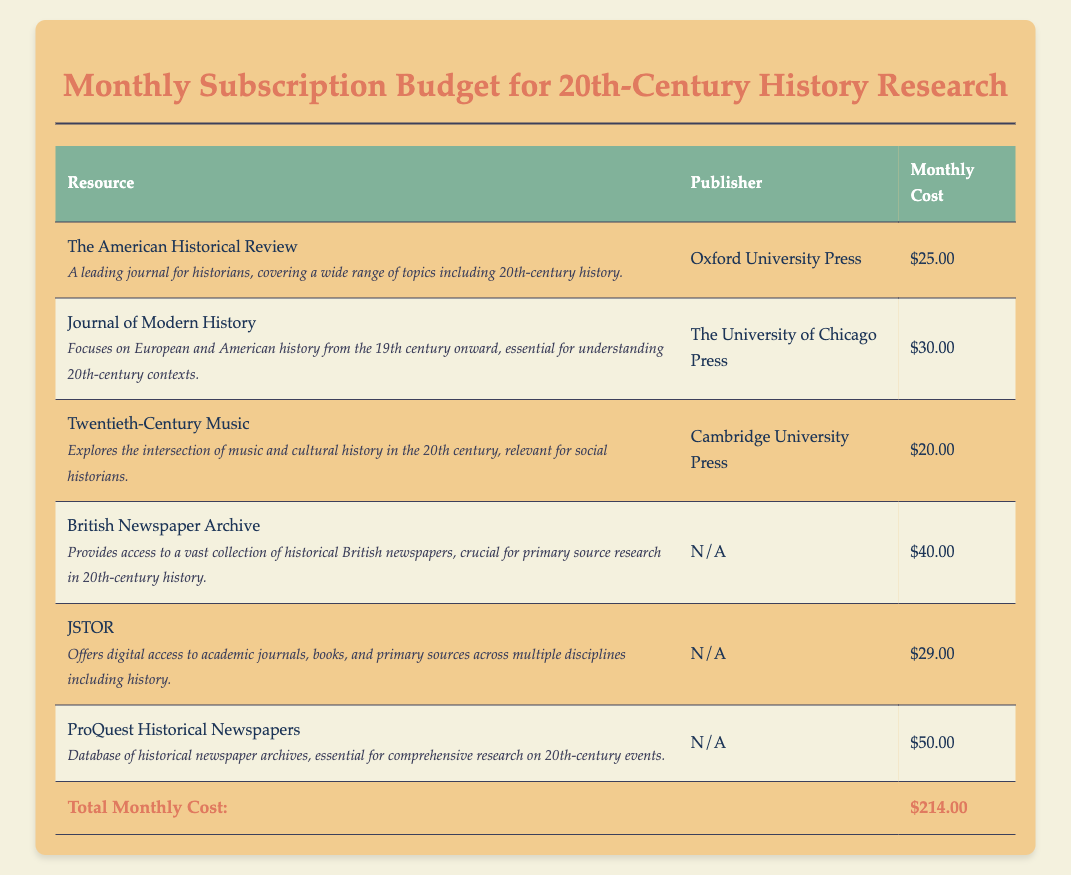What is the total monthly cost? The total monthly cost is listed at the bottom of the document in the table.
Answer: $214.00 Which publisher produces the Journal of Modern History? The publisher of the Journal of Modern History is specified in the second row of the table.
Answer: The University of Chicago Press How much does access to the British Newspaper Archive cost monthly? The monthly cost for the British Newspaper Archive is shown in the corresponding row of the table.
Answer: $40.00 What kind of topics does The American Historical Review cover? The description under The American Historical Review in the table mentions a range of topics relevant to history.
Answer: 20th-century history Which resource has the highest monthly subscription cost? Comparing the monthly costs listed, the resource with the highest cost can be determined from the table.
Answer: ProQuest Historical Newspapers What is the primary focus of Twentieth-Century Music? The description under Twentieth-Century Music explains its relevance to history.
Answer: Intersection of music and cultural history Which resource provides digital access to multiple academic journals? The resource offering digital access to various academic materials is explicitly mentioned in the table.
Answer: JSTOR 